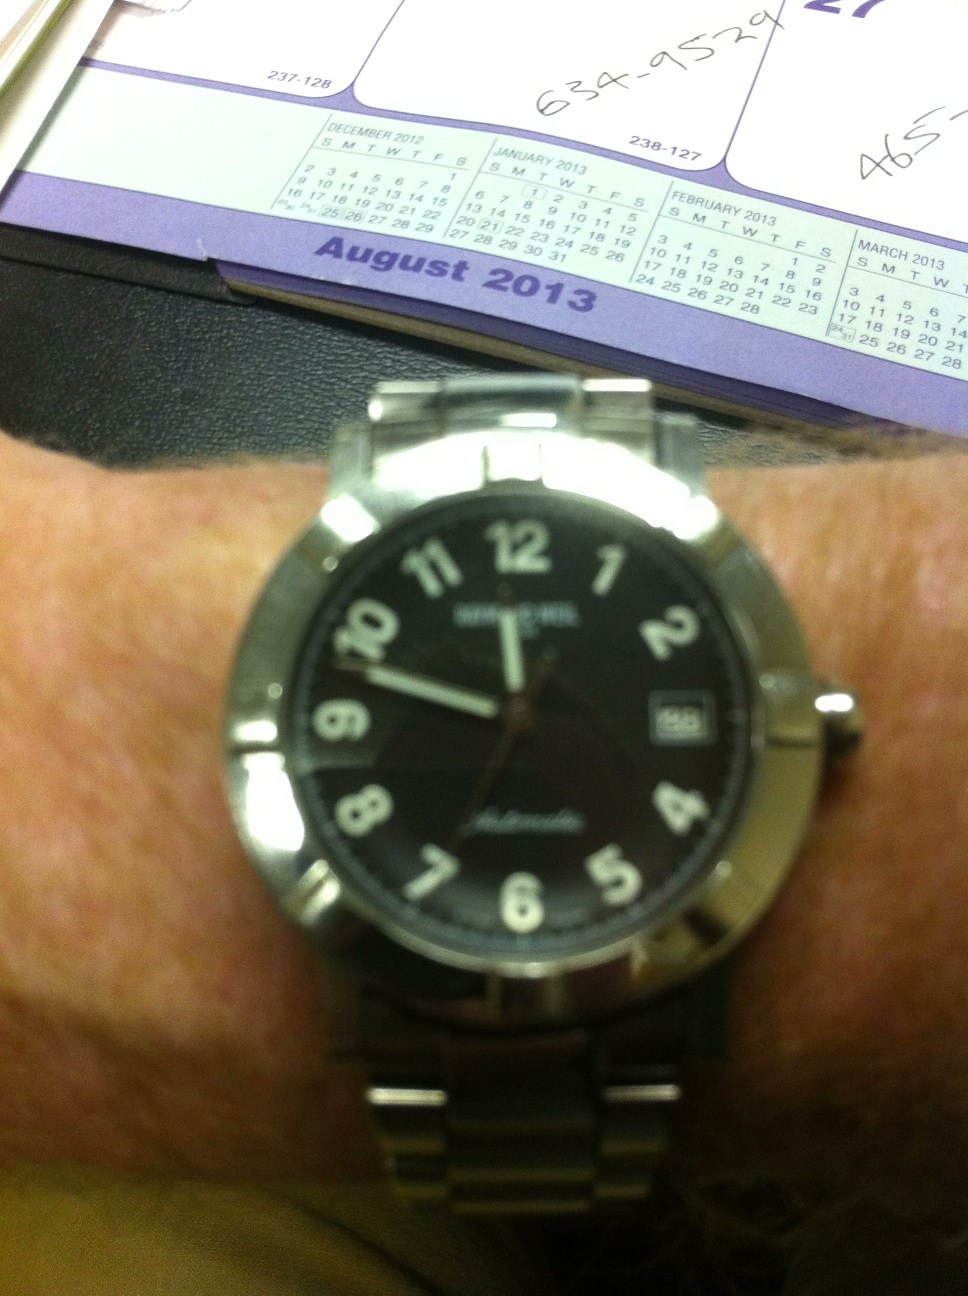Can you please tell me the time? from Vizwiz 11:48 